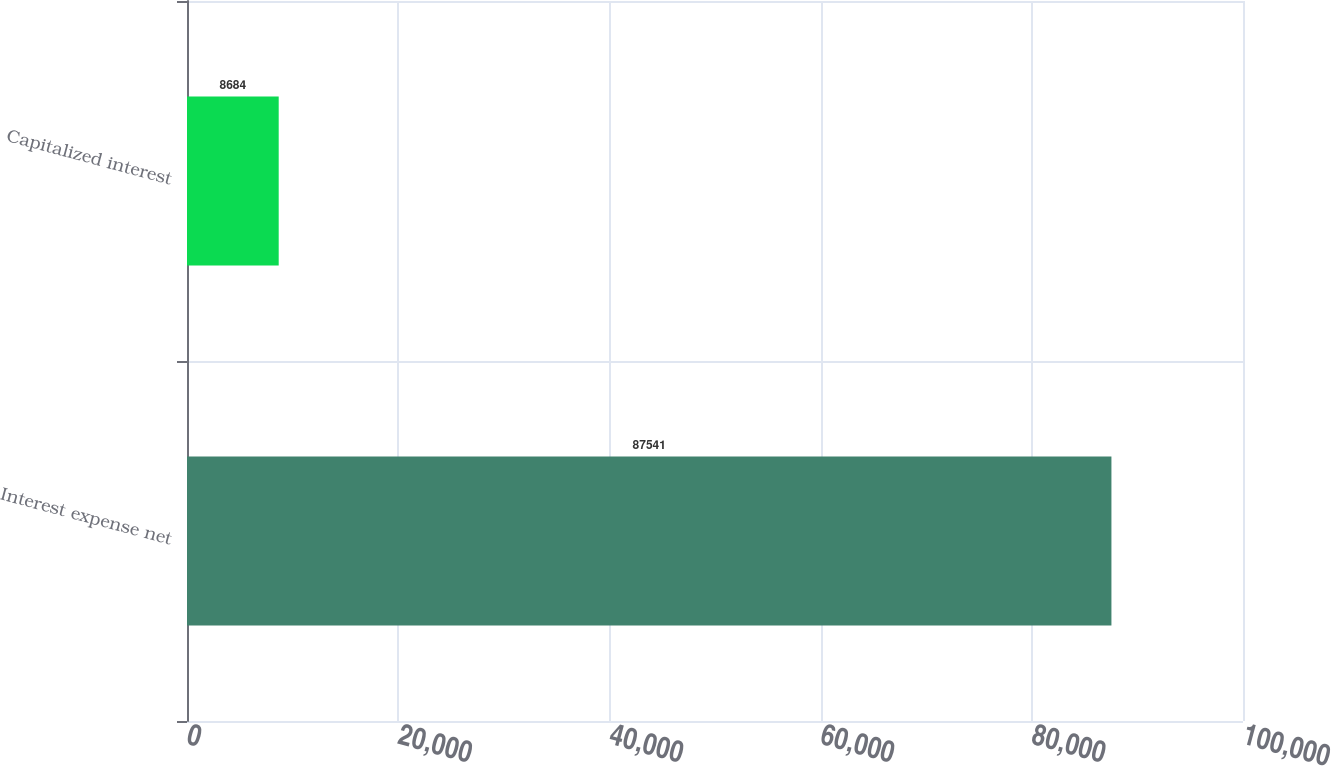<chart> <loc_0><loc_0><loc_500><loc_500><bar_chart><fcel>Interest expense net<fcel>Capitalized interest<nl><fcel>87541<fcel>8684<nl></chart> 